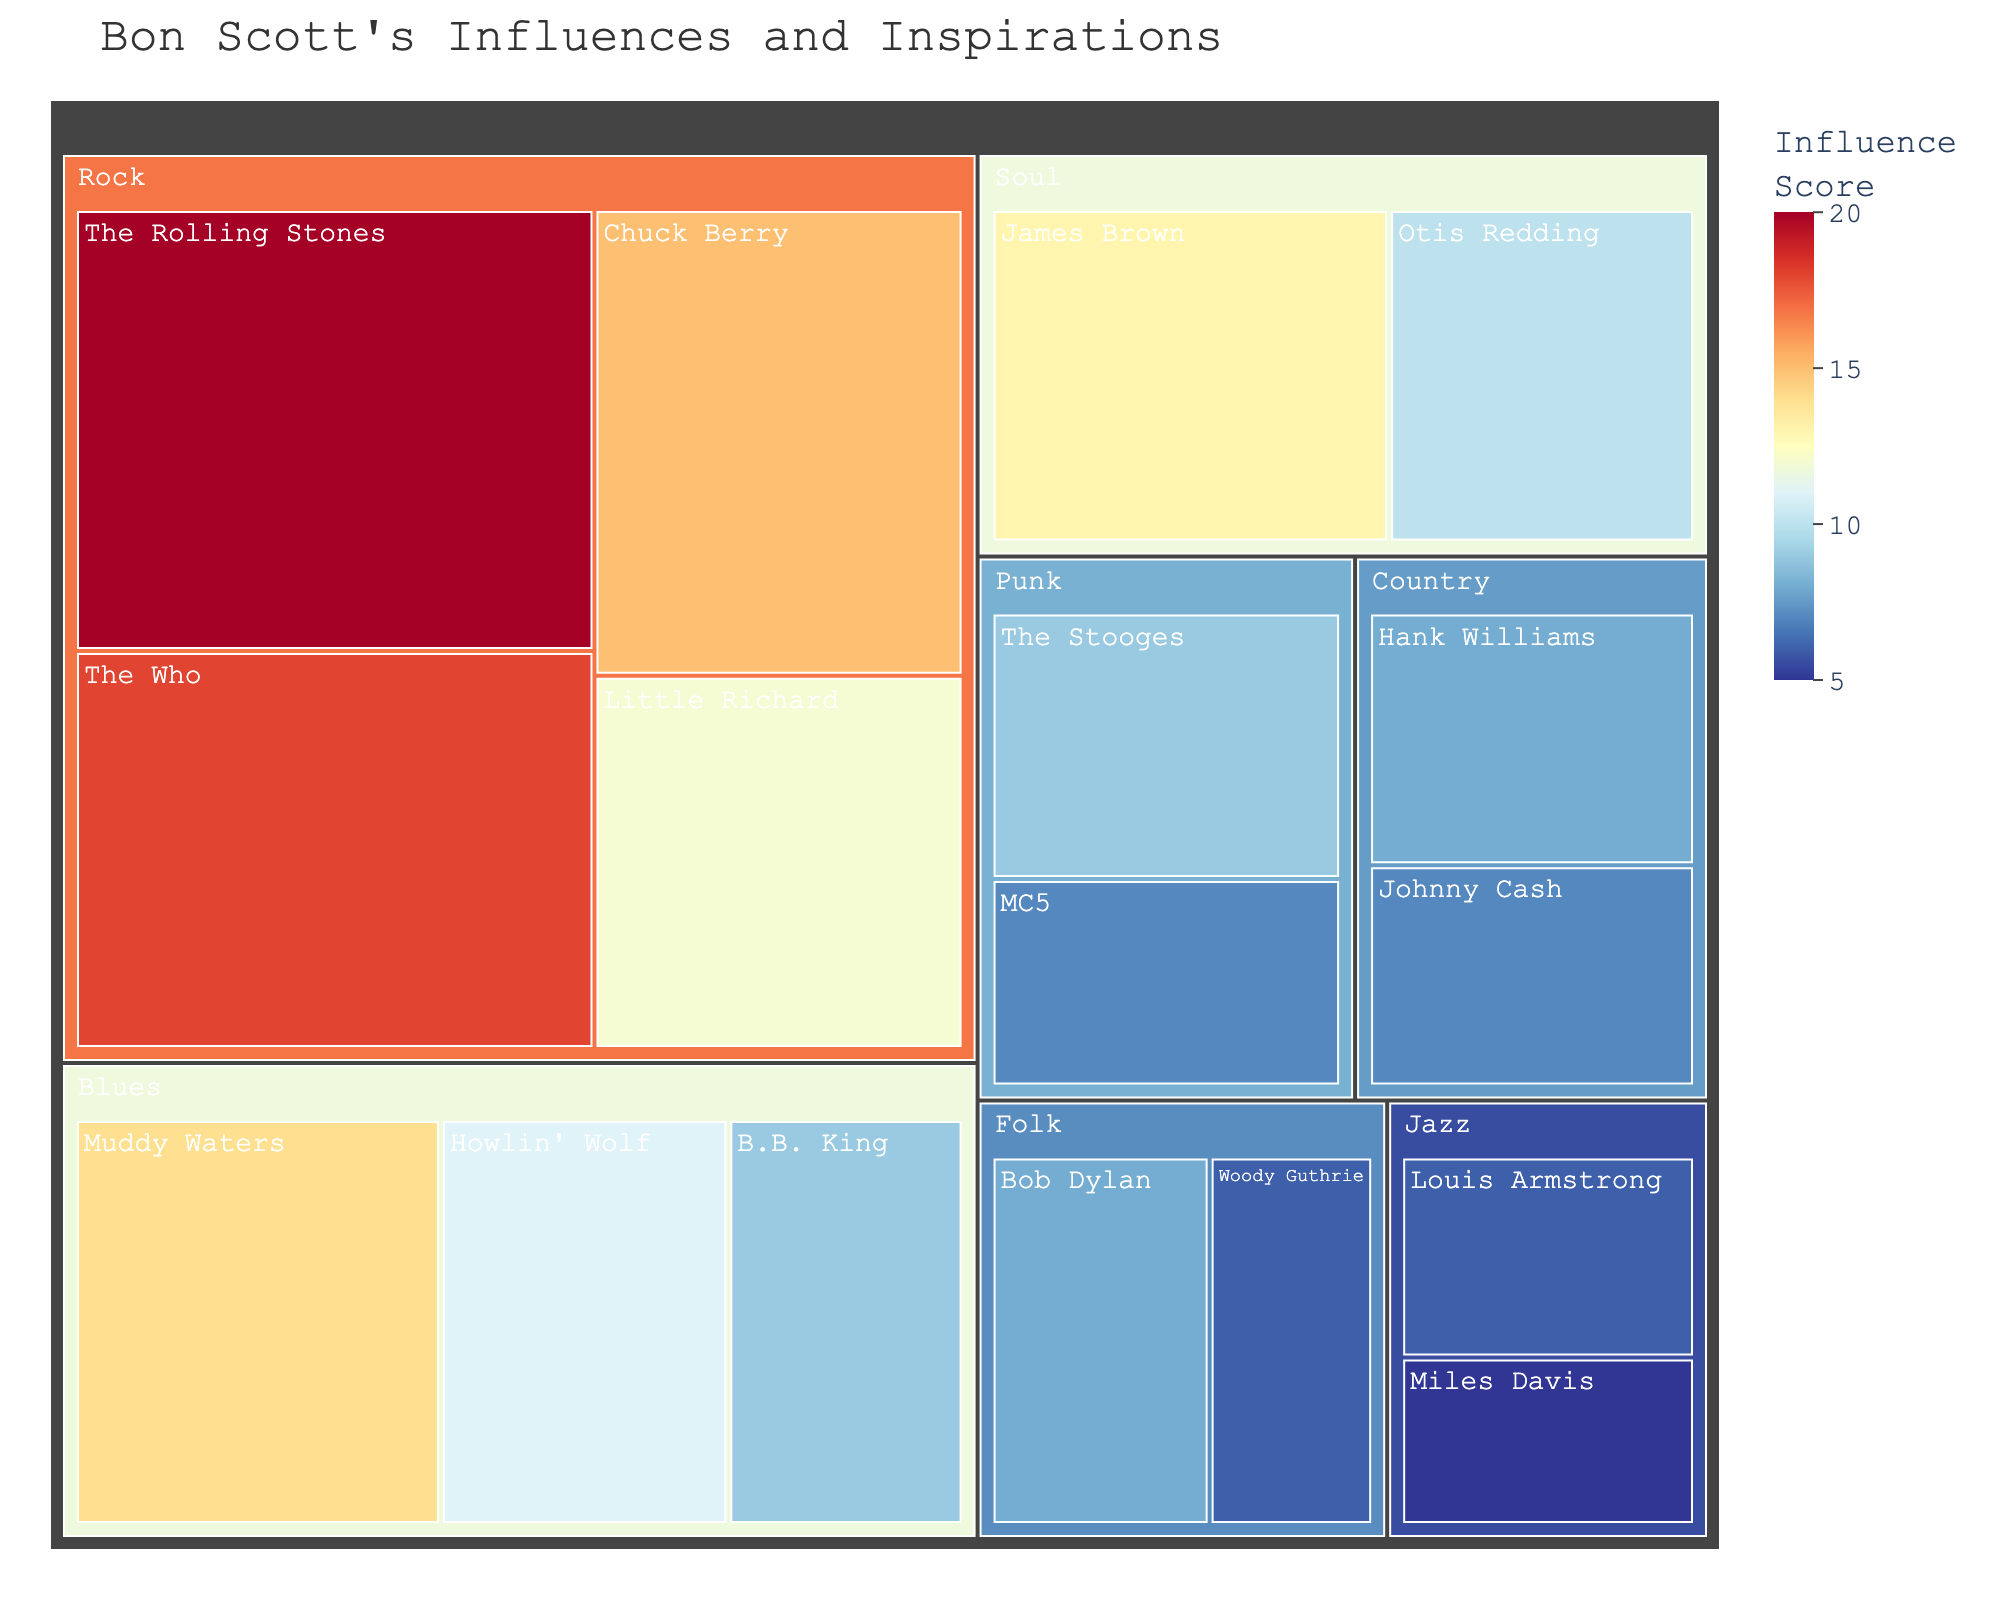What is the title of the Treemap? The title is usually displayed at the top of the Treemap. In this case, you can read the title directly from there.
Answer: Bon Scott's Influences and Inspirations Which musical genre has the highest influence score? To determine this, we need to look at the sum of influence scores for each genre. Summing them up: Rock (Chuck Berry 15 + Little Richard 12 + The Rolling Stones 20 + The Who 18 = 65), Blues (Muddy Waters 14 + Howlin' Wolf 11 + B.B. King 9 = 34), Country (Hank Williams 8 + Johnny Cash 7 = 15), Soul (James Brown 13 + Otis Redding 10 = 23), Jazz (Louis Armstrong 6 + Miles Davis 5 = 11), Folk (Bob Dylan 8 + Woody Guthrie 6 = 14), Punk (The Stooges 9 + MC5 7 = 16). Rock has the highest total influence score.
Answer: Rock What is the influence score of James Brown? Look at the Soul category in the Treemap and find the specific subcategory corresponding to James Brown. The influence score is displayed there.
Answer: 13 How many musical genres are represented in the Treemap? Count the number of unique categories listed in the Treemap. Each genre is visually separated, so count these sections.
Answer: 7 Which artist has the highest individual influence score? Compare the influence scores of all the individual artists listed in the Treemap. The artist with the highest score is The Rolling Stones with a score of 20.
Answer: The Rolling Stones What is the difference in influence scores between The Rolling Stones and Muddy Waters? Find the influence scores for both The Rolling Stones (20) and Muddy Waters (14). Subtract Muddy Waters' score from The Rolling Stones' score: 20 - 14 = 6.
Answer: 6 Which genre has the smallest total influence score? Sum the influence scores in each genre and identify the smallest sum. The genres and their sums are: Rock (65), Blues (34), Country (15), Soul (23), Jazz (11), Folk (14), Punk (16). Jazz has the smallest total influence score.
Answer: Jazz Is the influence score of The Who greater than that of Chuck Berry? Compare the influence scores for The Who (18) and Chuck Berry (15). The score for The Who is greater.
Answer: Yes Which artists have an influence score greater than 10? Identify and list all artists with scores above 10. Those artists are: Chuck Berry (15), Little Richard (12), The Rolling Stones (20), The Who (18), Muddy Waters (14), James Brown (13).
Answer: Chuck Berry, Little Richard, The Rolling Stones, The Who, Muddy Waters, James Brown 